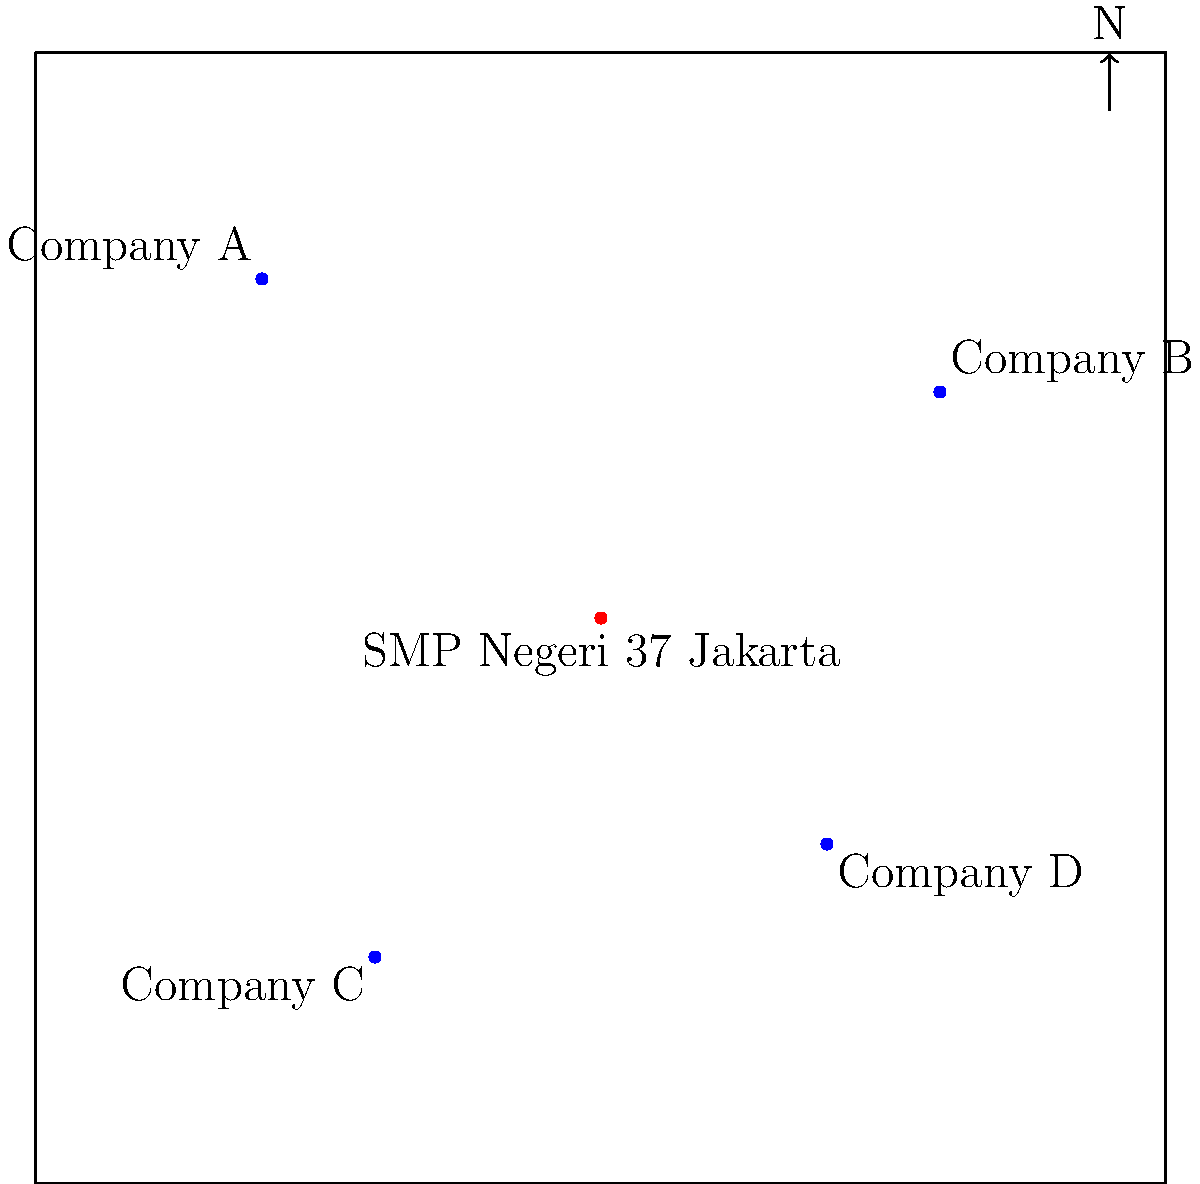Based on the map showing SMP Negeri 37 Jakarta and four major tech companies in Jakarta, which company is located closest to your alma mater? To determine which tech company is closest to SMP Negeri 37 Jakarta, we need to analyze the relative positions of each company on the map:

1. SMP Negeri 37 Jakarta is located at the center of the map.
2. Company A is in the northwest quadrant.
3. Company B is in the northeast quadrant.
4. Company C is in the southwest quadrant.
5. Company D is in the southeast quadrant.

To estimate the distances, we can visually compare the length of imaginary lines drawn from SMP Negeri 37 Jakarta to each company:

- The line to Company A would be relatively long.
- The line to Company B would be medium-long.
- The line to Company C appears to be the shortest.
- The line to Company D would be medium-short.

By visual inspection, Company C seems to be the closest to SMP Negeri 37 Jakarta.
Answer: Company C 